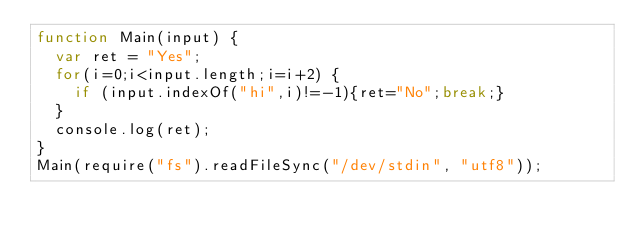<code> <loc_0><loc_0><loc_500><loc_500><_JavaScript_>function Main(input) {
  var ret = "Yes";
  for(i=0;i<input.length;i=i+2) {
    if (input.indexOf("hi",i)!=-1){ret="No";break;}
  }
  console.log(ret);
}
Main(require("fs").readFileSync("/dev/stdin", "utf8"));
</code> 